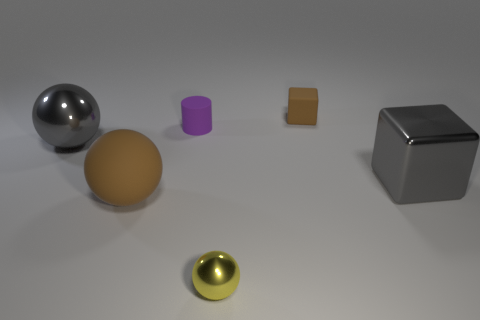Subtract all tiny yellow metallic balls. How many balls are left? 2 Subtract all gray balls. How many balls are left? 2 Subtract 1 cylinders. How many cylinders are left? 0 Subtract all cylinders. How many objects are left? 5 Add 4 large brown metallic blocks. How many large brown metallic blocks exist? 4 Add 3 small purple metal balls. How many objects exist? 9 Subtract 0 red cylinders. How many objects are left? 6 Subtract all green cylinders. Subtract all purple cubes. How many cylinders are left? 1 Subtract all purple spheres. How many cyan cubes are left? 0 Subtract all gray metal spheres. Subtract all green metal cylinders. How many objects are left? 5 